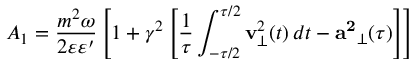Convert formula to latex. <formula><loc_0><loc_0><loc_500><loc_500>A _ { 1 } = \frac { m ^ { 2 } \omega } { 2 \varepsilon \varepsilon ^ { \prime } } \left [ 1 + \gamma ^ { 2 } \left [ \frac { 1 } { \tau } \int _ { - \tau / 2 } ^ { \tau / 2 } { v } _ { \perp } ^ { 2 } ( t ) \, d t - { a ^ { 2 } } _ { \perp } ( \tau ) \right ] \right ]</formula> 